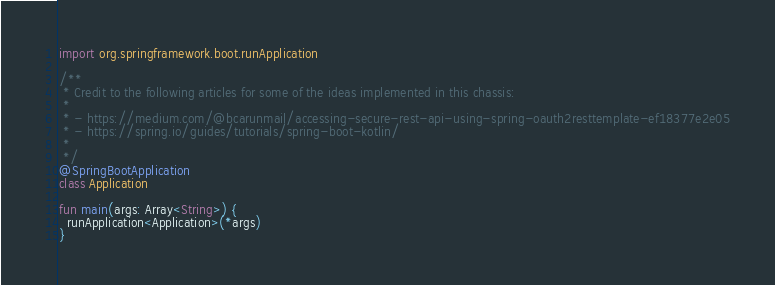Convert code to text. <code><loc_0><loc_0><loc_500><loc_500><_Kotlin_>import org.springframework.boot.runApplication

/**
 * Credit to the following articles for some of the ideas implemented in this chassis:
 *
 * - https://medium.com/@bcarunmail/accessing-secure-rest-api-using-spring-oauth2resttemplate-ef18377e2e05
 * - https://spring.io/guides/tutorials/spring-boot-kotlin/
 *
 */
@SpringBootApplication
class Application

fun main(args: Array<String>) {
  runApplication<Application>(*args)
}
</code> 